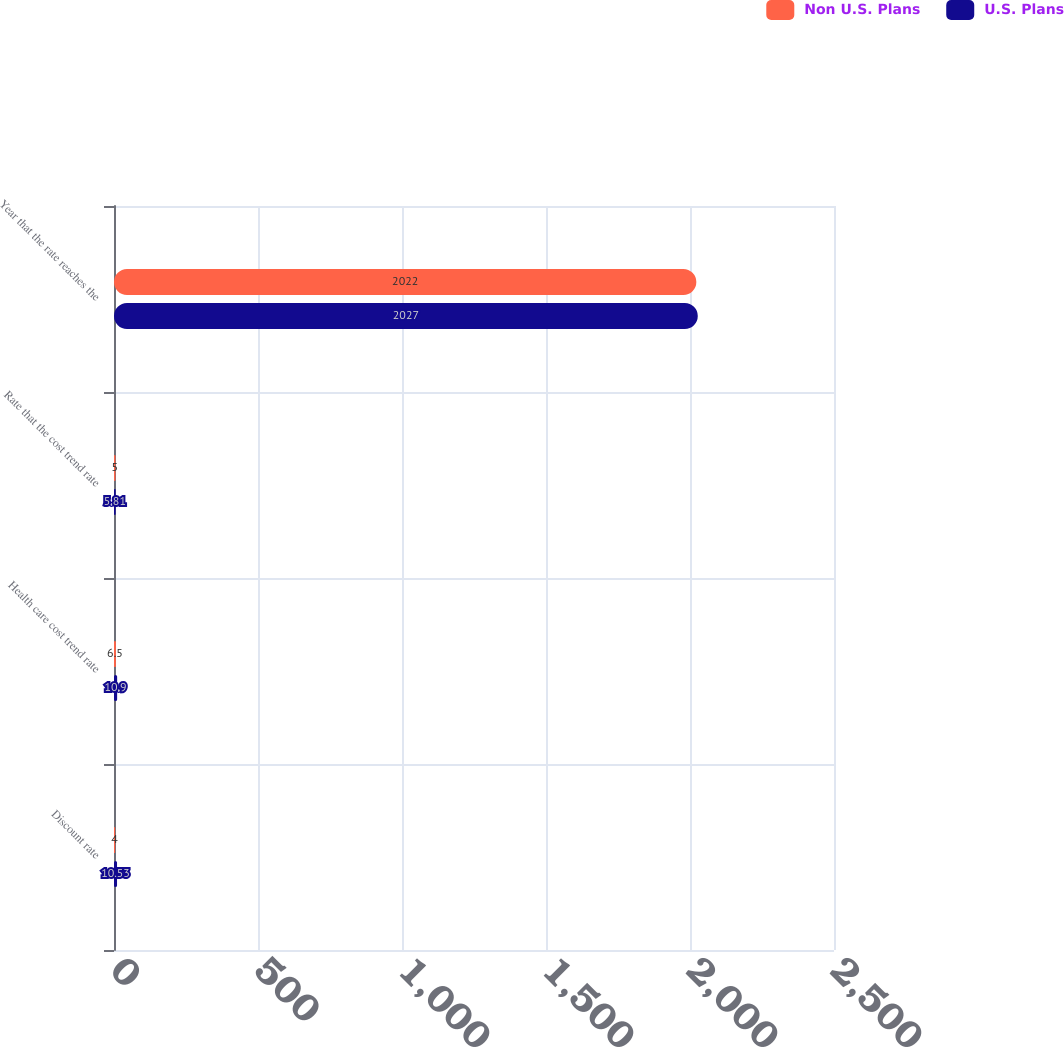<chart> <loc_0><loc_0><loc_500><loc_500><stacked_bar_chart><ecel><fcel>Discount rate<fcel>Health care cost trend rate<fcel>Rate that the cost trend rate<fcel>Year that the rate reaches the<nl><fcel>Non U.S. Plans<fcel>4<fcel>6.5<fcel>5<fcel>2022<nl><fcel>U.S. Plans<fcel>10.53<fcel>10.9<fcel>5.81<fcel>2027<nl></chart> 